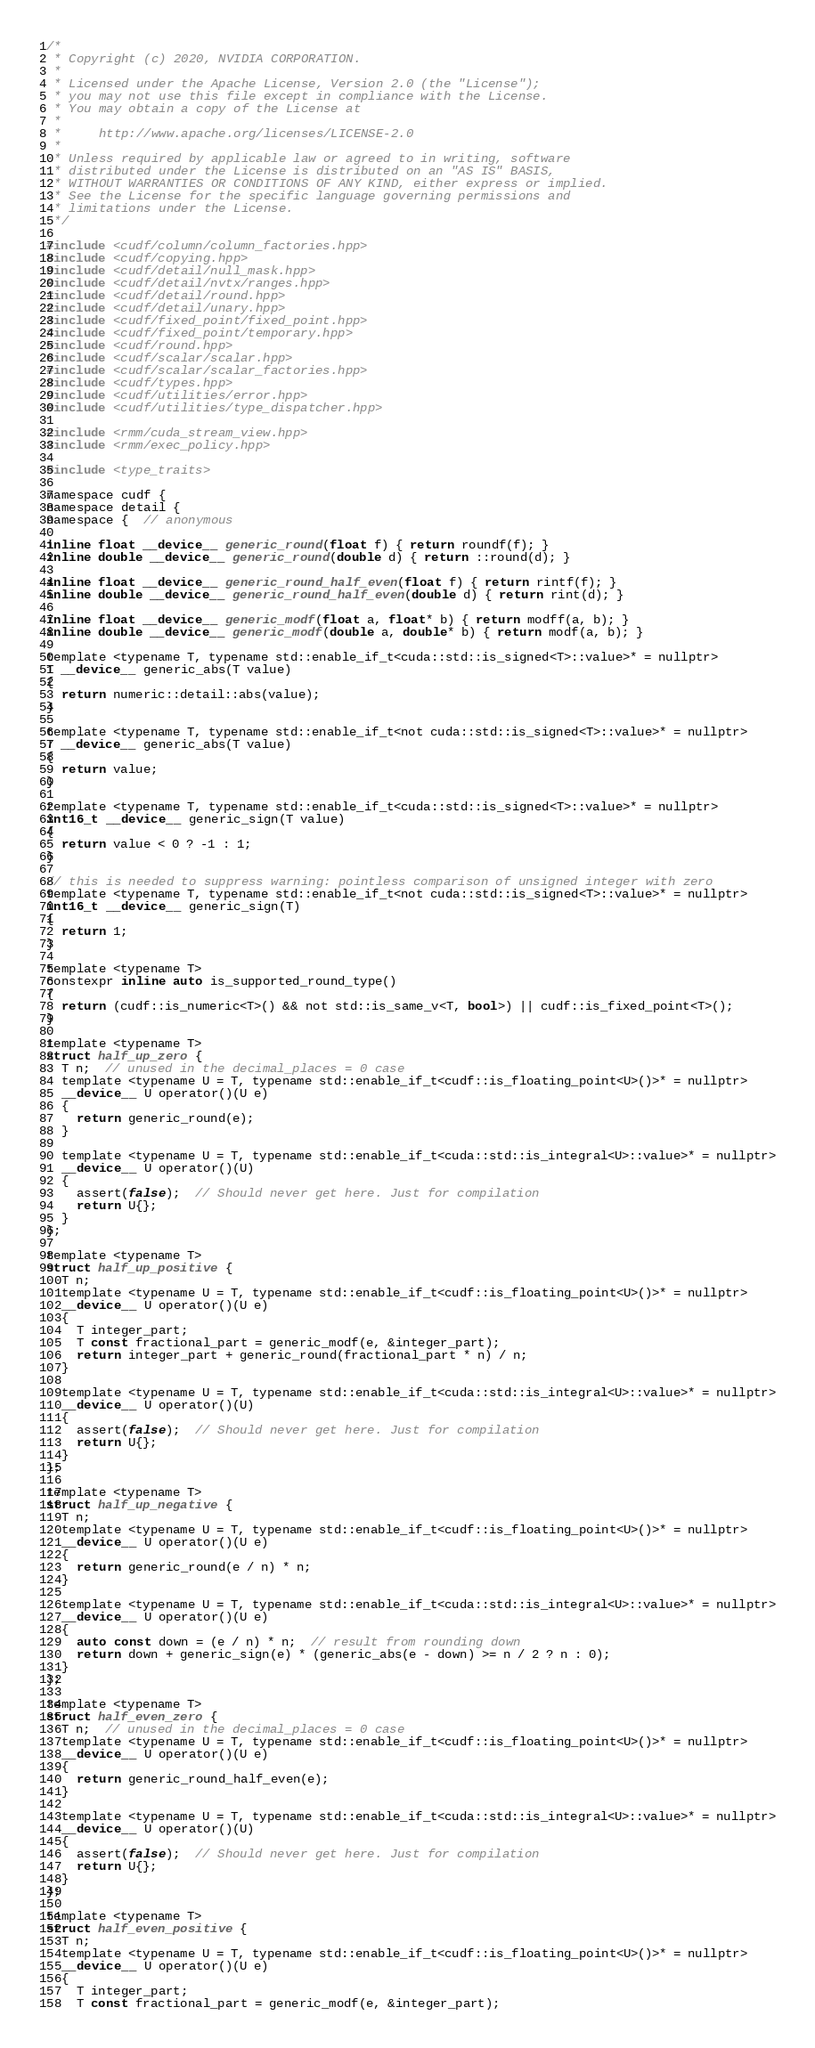<code> <loc_0><loc_0><loc_500><loc_500><_Cuda_>/*
 * Copyright (c) 2020, NVIDIA CORPORATION.
 *
 * Licensed under the Apache License, Version 2.0 (the "License");
 * you may not use this file except in compliance with the License.
 * You may obtain a copy of the License at
 *
 *     http://www.apache.org/licenses/LICENSE-2.0
 *
 * Unless required by applicable law or agreed to in writing, software
 * distributed under the License is distributed on an "AS IS" BASIS,
 * WITHOUT WARRANTIES OR CONDITIONS OF ANY KIND, either express or implied.
 * See the License for the specific language governing permissions and
 * limitations under the License.
 */

#include <cudf/column/column_factories.hpp>
#include <cudf/copying.hpp>
#include <cudf/detail/null_mask.hpp>
#include <cudf/detail/nvtx/ranges.hpp>
#include <cudf/detail/round.hpp>
#include <cudf/detail/unary.hpp>
#include <cudf/fixed_point/fixed_point.hpp>
#include <cudf/fixed_point/temporary.hpp>
#include <cudf/round.hpp>
#include <cudf/scalar/scalar.hpp>
#include <cudf/scalar/scalar_factories.hpp>
#include <cudf/types.hpp>
#include <cudf/utilities/error.hpp>
#include <cudf/utilities/type_dispatcher.hpp>

#include <rmm/cuda_stream_view.hpp>
#include <rmm/exec_policy.hpp>

#include <type_traits>

namespace cudf {
namespace detail {
namespace {  // anonymous

inline float __device__ generic_round(float f) { return roundf(f); }
inline double __device__ generic_round(double d) { return ::round(d); }

inline float __device__ generic_round_half_even(float f) { return rintf(f); }
inline double __device__ generic_round_half_even(double d) { return rint(d); }

inline float __device__ generic_modf(float a, float* b) { return modff(a, b); }
inline double __device__ generic_modf(double a, double* b) { return modf(a, b); }

template <typename T, typename std::enable_if_t<cuda::std::is_signed<T>::value>* = nullptr>
T __device__ generic_abs(T value)
{
  return numeric::detail::abs(value);
}

template <typename T, typename std::enable_if_t<not cuda::std::is_signed<T>::value>* = nullptr>
T __device__ generic_abs(T value)
{
  return value;
}

template <typename T, typename std::enable_if_t<cuda::std::is_signed<T>::value>* = nullptr>
int16_t __device__ generic_sign(T value)
{
  return value < 0 ? -1 : 1;
}

// this is needed to suppress warning: pointless comparison of unsigned integer with zero
template <typename T, typename std::enable_if_t<not cuda::std::is_signed<T>::value>* = nullptr>
int16_t __device__ generic_sign(T)
{
  return 1;
}

template <typename T>
constexpr inline auto is_supported_round_type()
{
  return (cudf::is_numeric<T>() && not std::is_same_v<T, bool>) || cudf::is_fixed_point<T>();
}

template <typename T>
struct half_up_zero {
  T n;  // unused in the decimal_places = 0 case
  template <typename U = T, typename std::enable_if_t<cudf::is_floating_point<U>()>* = nullptr>
  __device__ U operator()(U e)
  {
    return generic_round(e);
  }

  template <typename U = T, typename std::enable_if_t<cuda::std::is_integral<U>::value>* = nullptr>
  __device__ U operator()(U)
  {
    assert(false);  // Should never get here. Just for compilation
    return U{};
  }
};

template <typename T>
struct half_up_positive {
  T n;
  template <typename U = T, typename std::enable_if_t<cudf::is_floating_point<U>()>* = nullptr>
  __device__ U operator()(U e)
  {
    T integer_part;
    T const fractional_part = generic_modf(e, &integer_part);
    return integer_part + generic_round(fractional_part * n) / n;
  }

  template <typename U = T, typename std::enable_if_t<cuda::std::is_integral<U>::value>* = nullptr>
  __device__ U operator()(U)
  {
    assert(false);  // Should never get here. Just for compilation
    return U{};
  }
};

template <typename T>
struct half_up_negative {
  T n;
  template <typename U = T, typename std::enable_if_t<cudf::is_floating_point<U>()>* = nullptr>
  __device__ U operator()(U e)
  {
    return generic_round(e / n) * n;
  }

  template <typename U = T, typename std::enable_if_t<cuda::std::is_integral<U>::value>* = nullptr>
  __device__ U operator()(U e)
  {
    auto const down = (e / n) * n;  // result from rounding down
    return down + generic_sign(e) * (generic_abs(e - down) >= n / 2 ? n : 0);
  }
};

template <typename T>
struct half_even_zero {
  T n;  // unused in the decimal_places = 0 case
  template <typename U = T, typename std::enable_if_t<cudf::is_floating_point<U>()>* = nullptr>
  __device__ U operator()(U e)
  {
    return generic_round_half_even(e);
  }

  template <typename U = T, typename std::enable_if_t<cuda::std::is_integral<U>::value>* = nullptr>
  __device__ U operator()(U)
  {
    assert(false);  // Should never get here. Just for compilation
    return U{};
  }
};

template <typename T>
struct half_even_positive {
  T n;
  template <typename U = T, typename std::enable_if_t<cudf::is_floating_point<U>()>* = nullptr>
  __device__ U operator()(U e)
  {
    T integer_part;
    T const fractional_part = generic_modf(e, &integer_part);</code> 